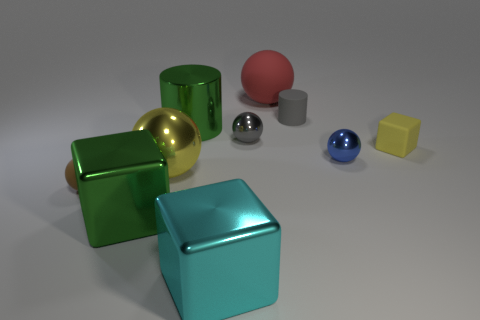Subtract all blue balls. How many balls are left? 4 Subtract all red rubber balls. How many balls are left? 4 Subtract all purple balls. Subtract all purple blocks. How many balls are left? 5 Subtract all cylinders. How many objects are left? 8 Add 7 red spheres. How many red spheres exist? 8 Subtract 0 cyan cylinders. How many objects are left? 10 Subtract all blue shiny spheres. Subtract all big green cylinders. How many objects are left? 8 Add 1 yellow metal objects. How many yellow metal objects are left? 2 